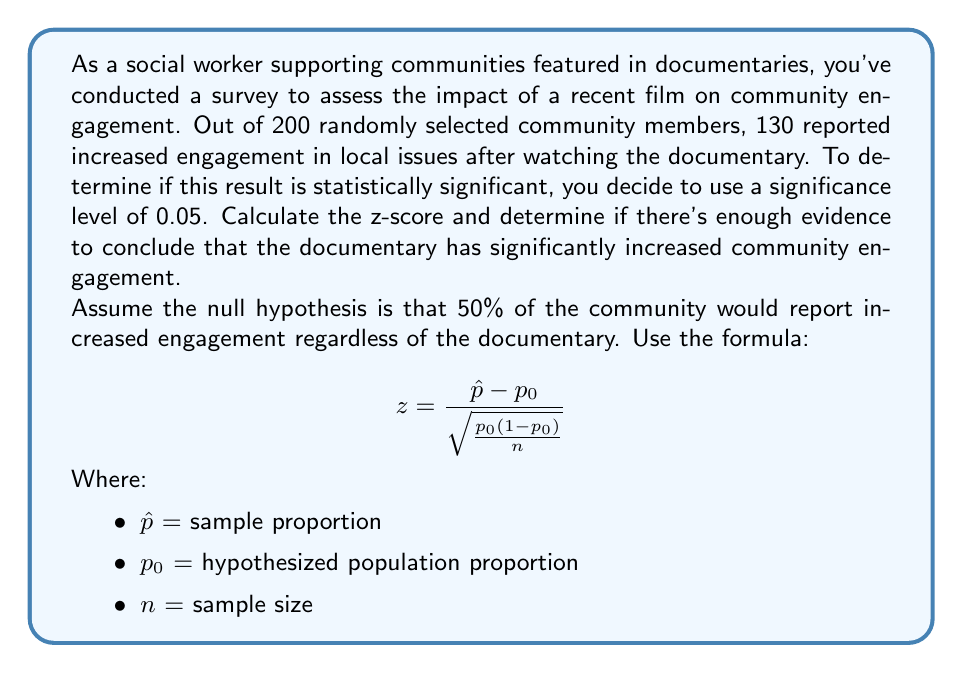Can you answer this question? To solve this problem, we'll follow these steps:

1) First, let's identify our values:
   $\hat{p} = 130/200 = 0.65$ (sample proportion)
   $p_0 = 0.5$ (null hypothesis proportion)
   $n = 200$ (sample size)

2) Now, let's plug these values into our z-score formula:

   $$ z = \frac{0.65 - 0.5}{\sqrt{\frac{0.5(1-0.5)}{200}}} $$

3) Simplify the denominator:
   $$ z = \frac{0.15}{\sqrt{\frac{0.25}{200}}} = \frac{0.15}{\sqrt{0.00125}} $$

4) Calculate the square root in the denominator:
   $$ z = \frac{0.15}{0.0353553} $$

5) Divide to get the final z-score:
   $$ z \approx 4.24 $$

6) To determine statistical significance, we compare this z-score to the critical value for a two-tailed test at α = 0.05, which is ±1.96.

   Since 4.24 > 1.96, we reject the null hypothesis.

Therefore, there is sufficient evidence to conclude that the documentary has significantly increased community engagement at the 0.05 significance level.
Answer: The z-score is approximately 4.24, which is greater than the critical value of 1.96 for a two-tailed test at α = 0.05. Therefore, we reject the null hypothesis and conclude that there is statistically significant evidence that the documentary has increased community engagement. 